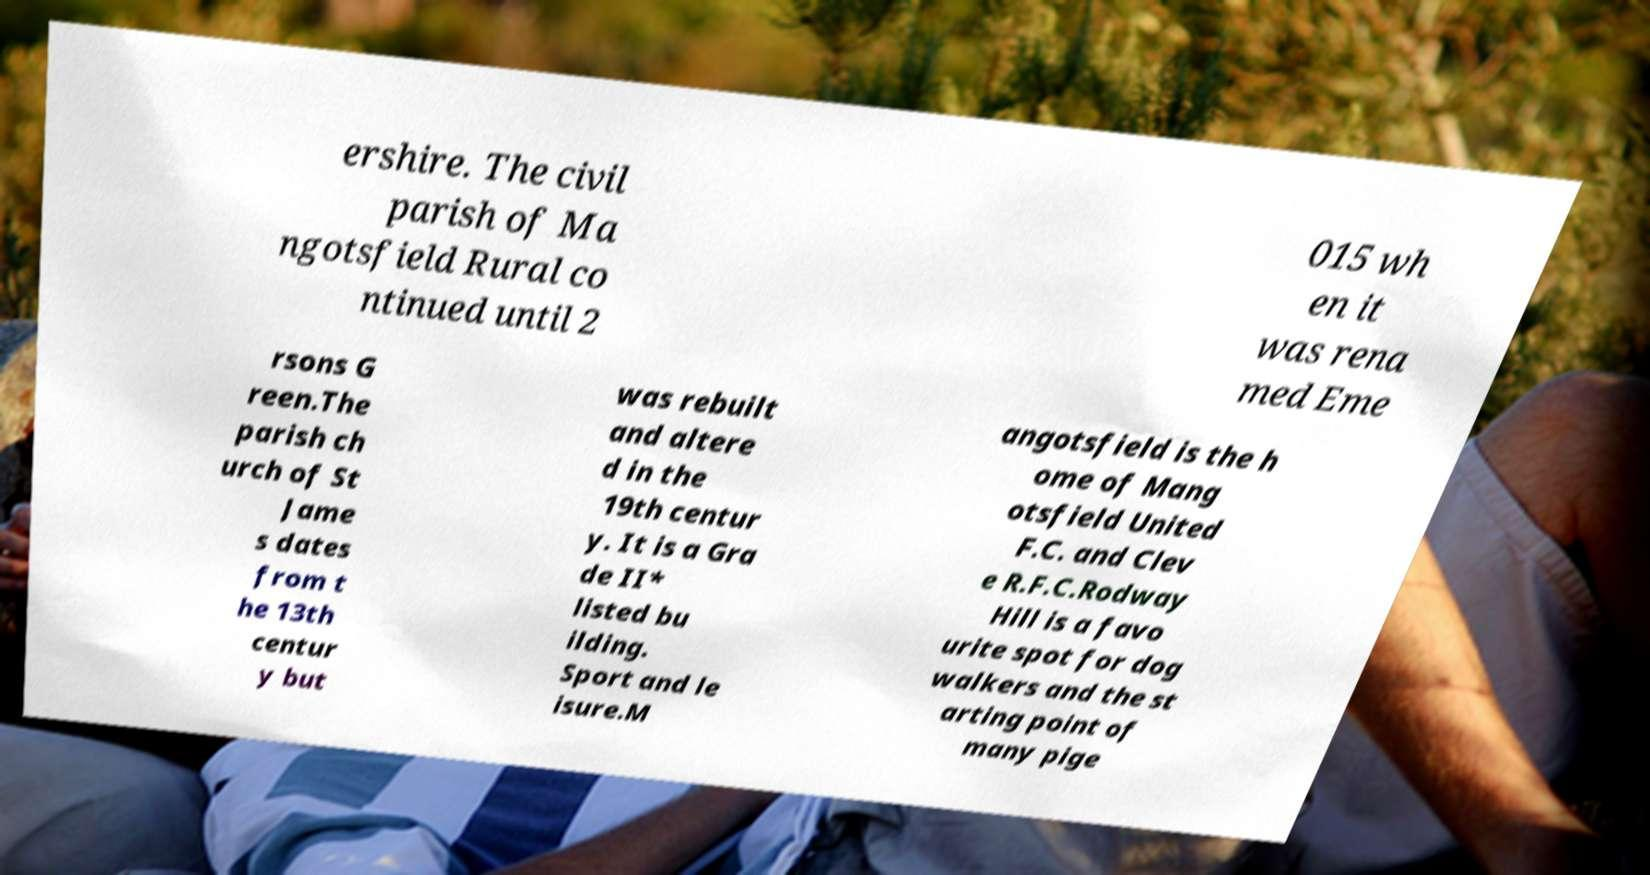I need the written content from this picture converted into text. Can you do that? ershire. The civil parish of Ma ngotsfield Rural co ntinued until 2 015 wh en it was rena med Eme rsons G reen.The parish ch urch of St Jame s dates from t he 13th centur y but was rebuilt and altere d in the 19th centur y. It is a Gra de II* listed bu ilding. Sport and le isure.M angotsfield is the h ome of Mang otsfield United F.C. and Clev e R.F.C.Rodway Hill is a favo urite spot for dog walkers and the st arting point of many pige 